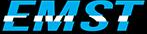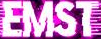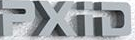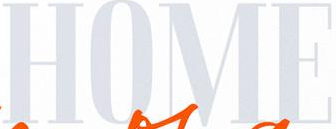What text appears in these images from left to right, separated by a semicolon? EMST; EMST; PXiD; HOME 